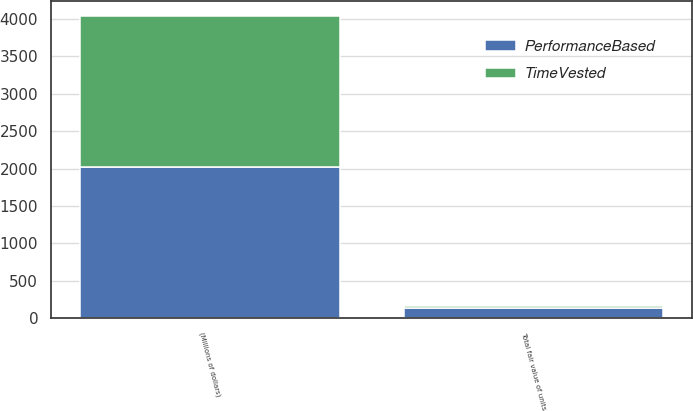<chart> <loc_0><loc_0><loc_500><loc_500><stacked_bar_chart><ecel><fcel>(Millions of dollars)<fcel>Total fair value of units<nl><fcel>TimeVested<fcel>2017<fcel>32<nl><fcel>PerformanceBased<fcel>2017<fcel>139<nl></chart> 